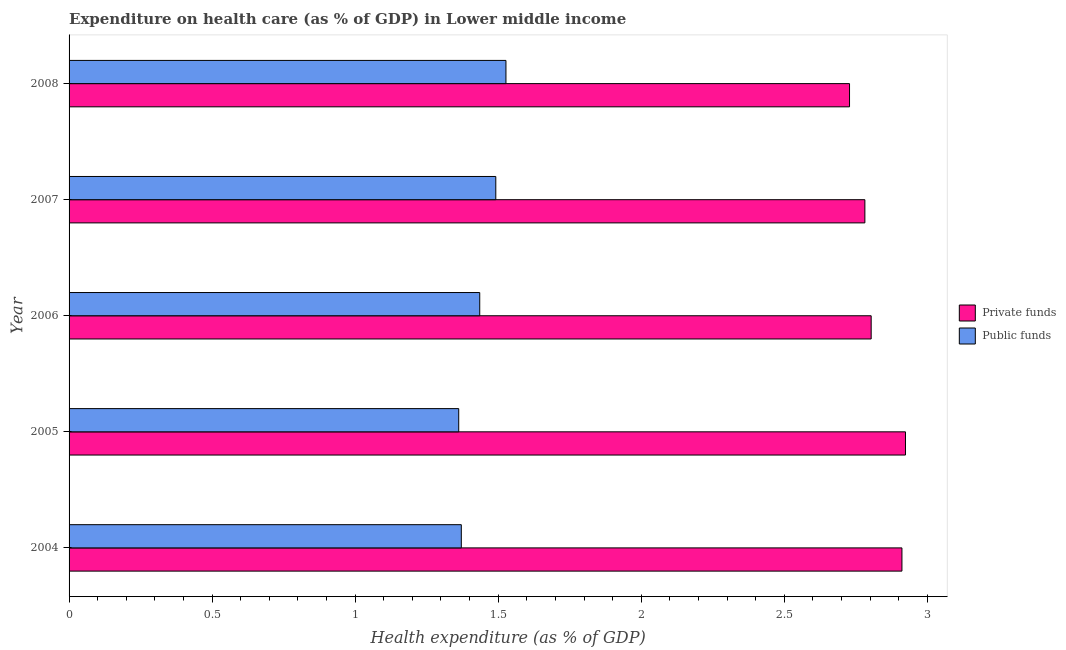How many different coloured bars are there?
Provide a succinct answer. 2. How many bars are there on the 4th tick from the top?
Offer a terse response. 2. How many bars are there on the 4th tick from the bottom?
Offer a very short reply. 2. In how many cases, is the number of bars for a given year not equal to the number of legend labels?
Keep it short and to the point. 0. What is the amount of public funds spent in healthcare in 2005?
Provide a short and direct response. 1.36. Across all years, what is the maximum amount of private funds spent in healthcare?
Ensure brevity in your answer.  2.92. Across all years, what is the minimum amount of public funds spent in healthcare?
Offer a very short reply. 1.36. What is the total amount of public funds spent in healthcare in the graph?
Offer a terse response. 7.19. What is the difference between the amount of private funds spent in healthcare in 2006 and that in 2008?
Your answer should be very brief. 0.08. What is the difference between the amount of private funds spent in healthcare in 2008 and the amount of public funds spent in healthcare in 2005?
Offer a very short reply. 1.37. What is the average amount of private funds spent in healthcare per year?
Offer a very short reply. 2.83. In the year 2006, what is the difference between the amount of public funds spent in healthcare and amount of private funds spent in healthcare?
Keep it short and to the point. -1.37. What is the ratio of the amount of private funds spent in healthcare in 2004 to that in 2005?
Make the answer very short. 1. Is the difference between the amount of public funds spent in healthcare in 2004 and 2008 greater than the difference between the amount of private funds spent in healthcare in 2004 and 2008?
Your answer should be compact. No. What is the difference between the highest and the second highest amount of public funds spent in healthcare?
Your answer should be compact. 0.04. What is the difference between the highest and the lowest amount of public funds spent in healthcare?
Provide a short and direct response. 0.17. In how many years, is the amount of public funds spent in healthcare greater than the average amount of public funds spent in healthcare taken over all years?
Give a very brief answer. 2. What does the 2nd bar from the top in 2007 represents?
Your answer should be compact. Private funds. What does the 1st bar from the bottom in 2006 represents?
Provide a short and direct response. Private funds. Are all the bars in the graph horizontal?
Provide a succinct answer. Yes. How many years are there in the graph?
Provide a succinct answer. 5. What is the difference between two consecutive major ticks on the X-axis?
Provide a short and direct response. 0.5. Are the values on the major ticks of X-axis written in scientific E-notation?
Keep it short and to the point. No. Does the graph contain any zero values?
Your answer should be very brief. No. Does the graph contain grids?
Offer a terse response. No. Where does the legend appear in the graph?
Offer a very short reply. Center right. How many legend labels are there?
Provide a short and direct response. 2. How are the legend labels stacked?
Provide a short and direct response. Vertical. What is the title of the graph?
Keep it short and to the point. Expenditure on health care (as % of GDP) in Lower middle income. Does "Adolescent fertility rate" appear as one of the legend labels in the graph?
Your answer should be compact. No. What is the label or title of the X-axis?
Make the answer very short. Health expenditure (as % of GDP). What is the label or title of the Y-axis?
Make the answer very short. Year. What is the Health expenditure (as % of GDP) of Private funds in 2004?
Keep it short and to the point. 2.91. What is the Health expenditure (as % of GDP) of Public funds in 2004?
Make the answer very short. 1.37. What is the Health expenditure (as % of GDP) of Private funds in 2005?
Offer a terse response. 2.92. What is the Health expenditure (as % of GDP) of Public funds in 2005?
Your answer should be compact. 1.36. What is the Health expenditure (as % of GDP) of Private funds in 2006?
Provide a short and direct response. 2.8. What is the Health expenditure (as % of GDP) of Public funds in 2006?
Your answer should be very brief. 1.44. What is the Health expenditure (as % of GDP) of Private funds in 2007?
Offer a very short reply. 2.78. What is the Health expenditure (as % of GDP) of Public funds in 2007?
Offer a very short reply. 1.49. What is the Health expenditure (as % of GDP) in Private funds in 2008?
Give a very brief answer. 2.73. What is the Health expenditure (as % of GDP) in Public funds in 2008?
Ensure brevity in your answer.  1.53. Across all years, what is the maximum Health expenditure (as % of GDP) of Private funds?
Ensure brevity in your answer.  2.92. Across all years, what is the maximum Health expenditure (as % of GDP) of Public funds?
Offer a terse response. 1.53. Across all years, what is the minimum Health expenditure (as % of GDP) in Private funds?
Offer a terse response. 2.73. Across all years, what is the minimum Health expenditure (as % of GDP) of Public funds?
Ensure brevity in your answer.  1.36. What is the total Health expenditure (as % of GDP) in Private funds in the graph?
Offer a very short reply. 14.15. What is the total Health expenditure (as % of GDP) in Public funds in the graph?
Provide a succinct answer. 7.19. What is the difference between the Health expenditure (as % of GDP) of Private funds in 2004 and that in 2005?
Offer a very short reply. -0.01. What is the difference between the Health expenditure (as % of GDP) of Public funds in 2004 and that in 2005?
Provide a short and direct response. 0.01. What is the difference between the Health expenditure (as % of GDP) of Private funds in 2004 and that in 2006?
Provide a succinct answer. 0.11. What is the difference between the Health expenditure (as % of GDP) in Public funds in 2004 and that in 2006?
Offer a very short reply. -0.06. What is the difference between the Health expenditure (as % of GDP) of Private funds in 2004 and that in 2007?
Offer a terse response. 0.13. What is the difference between the Health expenditure (as % of GDP) of Public funds in 2004 and that in 2007?
Your response must be concise. -0.12. What is the difference between the Health expenditure (as % of GDP) in Private funds in 2004 and that in 2008?
Offer a terse response. 0.18. What is the difference between the Health expenditure (as % of GDP) in Public funds in 2004 and that in 2008?
Keep it short and to the point. -0.16. What is the difference between the Health expenditure (as % of GDP) of Private funds in 2005 and that in 2006?
Ensure brevity in your answer.  0.12. What is the difference between the Health expenditure (as % of GDP) in Public funds in 2005 and that in 2006?
Provide a succinct answer. -0.07. What is the difference between the Health expenditure (as % of GDP) in Private funds in 2005 and that in 2007?
Give a very brief answer. 0.14. What is the difference between the Health expenditure (as % of GDP) in Public funds in 2005 and that in 2007?
Provide a succinct answer. -0.13. What is the difference between the Health expenditure (as % of GDP) of Private funds in 2005 and that in 2008?
Offer a very short reply. 0.2. What is the difference between the Health expenditure (as % of GDP) of Public funds in 2005 and that in 2008?
Keep it short and to the point. -0.17. What is the difference between the Health expenditure (as % of GDP) of Private funds in 2006 and that in 2007?
Offer a terse response. 0.02. What is the difference between the Health expenditure (as % of GDP) of Public funds in 2006 and that in 2007?
Offer a terse response. -0.06. What is the difference between the Health expenditure (as % of GDP) in Private funds in 2006 and that in 2008?
Make the answer very short. 0.08. What is the difference between the Health expenditure (as % of GDP) in Public funds in 2006 and that in 2008?
Provide a succinct answer. -0.09. What is the difference between the Health expenditure (as % of GDP) in Private funds in 2007 and that in 2008?
Your answer should be very brief. 0.05. What is the difference between the Health expenditure (as % of GDP) in Public funds in 2007 and that in 2008?
Offer a very short reply. -0.04. What is the difference between the Health expenditure (as % of GDP) of Private funds in 2004 and the Health expenditure (as % of GDP) of Public funds in 2005?
Provide a succinct answer. 1.55. What is the difference between the Health expenditure (as % of GDP) in Private funds in 2004 and the Health expenditure (as % of GDP) in Public funds in 2006?
Provide a succinct answer. 1.48. What is the difference between the Health expenditure (as % of GDP) in Private funds in 2004 and the Health expenditure (as % of GDP) in Public funds in 2007?
Provide a succinct answer. 1.42. What is the difference between the Health expenditure (as % of GDP) in Private funds in 2004 and the Health expenditure (as % of GDP) in Public funds in 2008?
Make the answer very short. 1.38. What is the difference between the Health expenditure (as % of GDP) in Private funds in 2005 and the Health expenditure (as % of GDP) in Public funds in 2006?
Give a very brief answer. 1.49. What is the difference between the Health expenditure (as % of GDP) of Private funds in 2005 and the Health expenditure (as % of GDP) of Public funds in 2007?
Provide a succinct answer. 1.43. What is the difference between the Health expenditure (as % of GDP) in Private funds in 2005 and the Health expenditure (as % of GDP) in Public funds in 2008?
Your answer should be very brief. 1.4. What is the difference between the Health expenditure (as % of GDP) in Private funds in 2006 and the Health expenditure (as % of GDP) in Public funds in 2007?
Offer a terse response. 1.31. What is the difference between the Health expenditure (as % of GDP) in Private funds in 2006 and the Health expenditure (as % of GDP) in Public funds in 2008?
Your response must be concise. 1.28. What is the difference between the Health expenditure (as % of GDP) of Private funds in 2007 and the Health expenditure (as % of GDP) of Public funds in 2008?
Provide a short and direct response. 1.25. What is the average Health expenditure (as % of GDP) in Private funds per year?
Offer a very short reply. 2.83. What is the average Health expenditure (as % of GDP) in Public funds per year?
Your answer should be compact. 1.44. In the year 2004, what is the difference between the Health expenditure (as % of GDP) in Private funds and Health expenditure (as % of GDP) in Public funds?
Give a very brief answer. 1.54. In the year 2005, what is the difference between the Health expenditure (as % of GDP) of Private funds and Health expenditure (as % of GDP) of Public funds?
Ensure brevity in your answer.  1.56. In the year 2006, what is the difference between the Health expenditure (as % of GDP) of Private funds and Health expenditure (as % of GDP) of Public funds?
Keep it short and to the point. 1.37. In the year 2007, what is the difference between the Health expenditure (as % of GDP) of Private funds and Health expenditure (as % of GDP) of Public funds?
Provide a succinct answer. 1.29. In the year 2008, what is the difference between the Health expenditure (as % of GDP) in Private funds and Health expenditure (as % of GDP) in Public funds?
Offer a terse response. 1.2. What is the ratio of the Health expenditure (as % of GDP) of Public funds in 2004 to that in 2005?
Provide a succinct answer. 1.01. What is the ratio of the Health expenditure (as % of GDP) of Private funds in 2004 to that in 2006?
Offer a very short reply. 1.04. What is the ratio of the Health expenditure (as % of GDP) of Public funds in 2004 to that in 2006?
Give a very brief answer. 0.96. What is the ratio of the Health expenditure (as % of GDP) of Private funds in 2004 to that in 2007?
Provide a succinct answer. 1.05. What is the ratio of the Health expenditure (as % of GDP) of Public funds in 2004 to that in 2007?
Provide a succinct answer. 0.92. What is the ratio of the Health expenditure (as % of GDP) of Private funds in 2004 to that in 2008?
Your answer should be compact. 1.07. What is the ratio of the Health expenditure (as % of GDP) in Public funds in 2004 to that in 2008?
Ensure brevity in your answer.  0.9. What is the ratio of the Health expenditure (as % of GDP) in Private funds in 2005 to that in 2006?
Make the answer very short. 1.04. What is the ratio of the Health expenditure (as % of GDP) in Public funds in 2005 to that in 2006?
Make the answer very short. 0.95. What is the ratio of the Health expenditure (as % of GDP) of Private funds in 2005 to that in 2007?
Your answer should be very brief. 1.05. What is the ratio of the Health expenditure (as % of GDP) in Public funds in 2005 to that in 2007?
Provide a short and direct response. 0.91. What is the ratio of the Health expenditure (as % of GDP) of Private funds in 2005 to that in 2008?
Give a very brief answer. 1.07. What is the ratio of the Health expenditure (as % of GDP) in Public funds in 2005 to that in 2008?
Ensure brevity in your answer.  0.89. What is the ratio of the Health expenditure (as % of GDP) of Private funds in 2006 to that in 2007?
Provide a short and direct response. 1.01. What is the ratio of the Health expenditure (as % of GDP) in Public funds in 2006 to that in 2007?
Offer a very short reply. 0.96. What is the ratio of the Health expenditure (as % of GDP) in Private funds in 2006 to that in 2008?
Make the answer very short. 1.03. What is the ratio of the Health expenditure (as % of GDP) in Public funds in 2006 to that in 2008?
Your answer should be very brief. 0.94. What is the ratio of the Health expenditure (as % of GDP) in Private funds in 2007 to that in 2008?
Give a very brief answer. 1.02. What is the ratio of the Health expenditure (as % of GDP) of Public funds in 2007 to that in 2008?
Ensure brevity in your answer.  0.98. What is the difference between the highest and the second highest Health expenditure (as % of GDP) of Private funds?
Your response must be concise. 0.01. What is the difference between the highest and the second highest Health expenditure (as % of GDP) of Public funds?
Your answer should be very brief. 0.04. What is the difference between the highest and the lowest Health expenditure (as % of GDP) of Private funds?
Offer a terse response. 0.2. What is the difference between the highest and the lowest Health expenditure (as % of GDP) of Public funds?
Your answer should be compact. 0.17. 